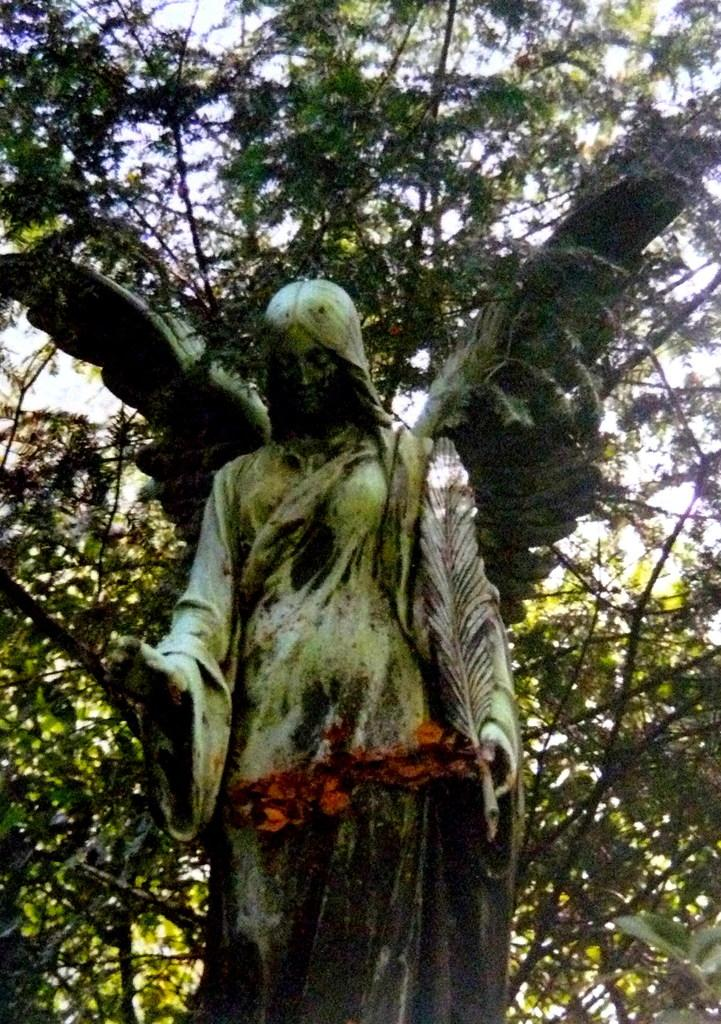What is the main subject of the image? There is a statue of an angel in the image. Where is the statue located in relation to other objects in the image? The statue is in front of a tree. What type of voyage did the angel undertake before being placed in the image? There is no information about any voyage undertaken by the angel in the image or the facts provided. 